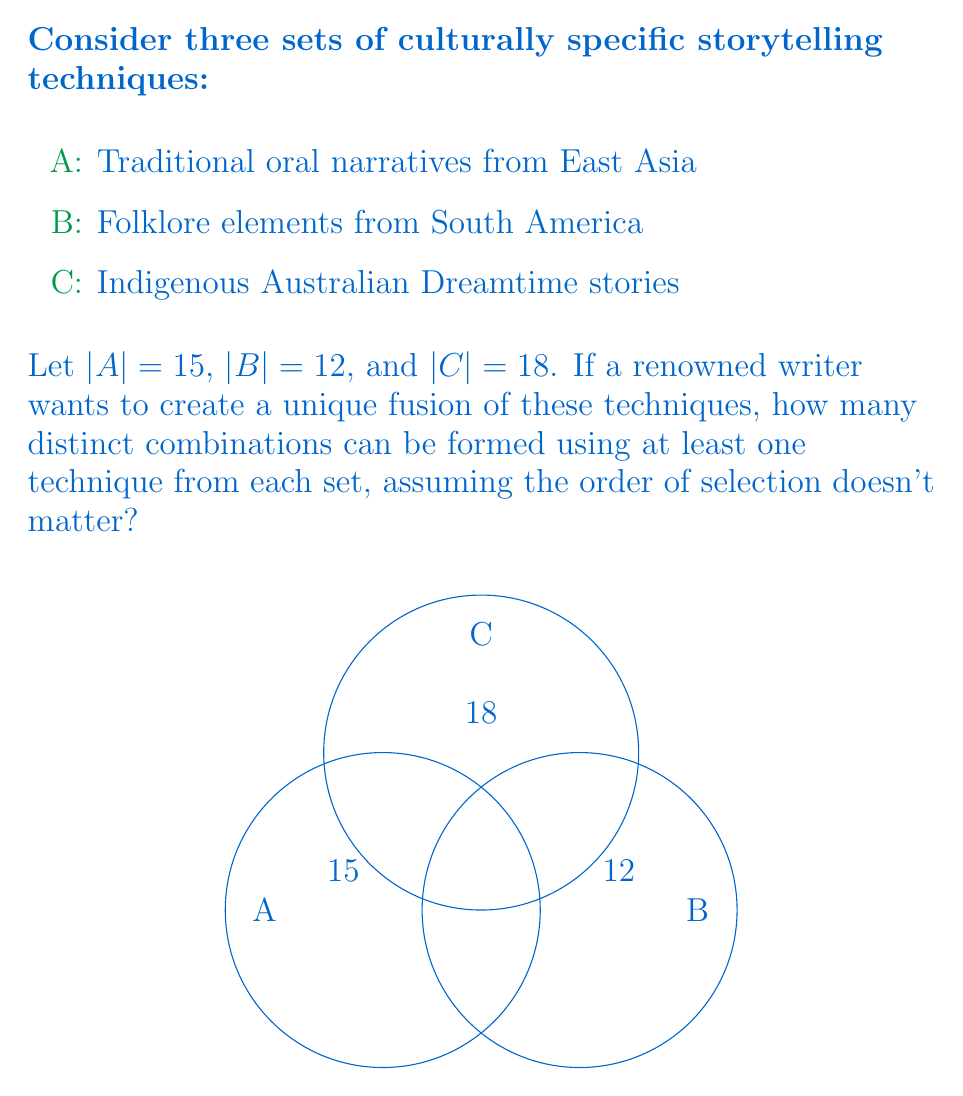Solve this math problem. To solve this problem, we'll use the principle of inclusion-exclusion and the concept of power sets.

Step 1: Calculate the total number of possible combinations from all three sets.
Total combinations = $2^{15} \cdot 2^{12} \cdot 2^{18} - 1 = 2^{45} - 1$
(We subtract 1 to exclude the empty set)

Step 2: Calculate the number of combinations that exclude at least one set.
Excluding A: $2^{12} \cdot 2^{18} - 1 = 2^{30} - 1$
Excluding B: $2^{15} \cdot 2^{18} - 1 = 2^{33} - 1$
Excluding C: $2^{15} \cdot 2^{12} - 1 = 2^{27} - 1$

Step 3: Apply the principle of inclusion-exclusion.
Desired combinations = Total - (Exclude A + Exclude B + Exclude C) + (Exclude AB + Exclude AC + Exclude BC) - Exclude ABC

$$ \begin{align*}
&= (2^{45} - 1) - [(2^{30} - 1) + (2^{33} - 1) + (2^{27} - 1)] \\
&\quad + [(2^{18} - 1) + (2^{12} - 1) + (2^{15} - 1)] - (2^0 - 1) \\
&= 2^{45} - 2^{30} - 2^{33} - 2^{27} + 2^{18} + 2^{12} + 2^{15} - 1
\end{align*} $$

Step 4: Simplify the expression.
$$ 35184372088832 - 1073741824 - 8589934592 - 134217728 + 262144 + 4096 + 32768 - 1 = 25380744389695 $$
Answer: 25380744389695 